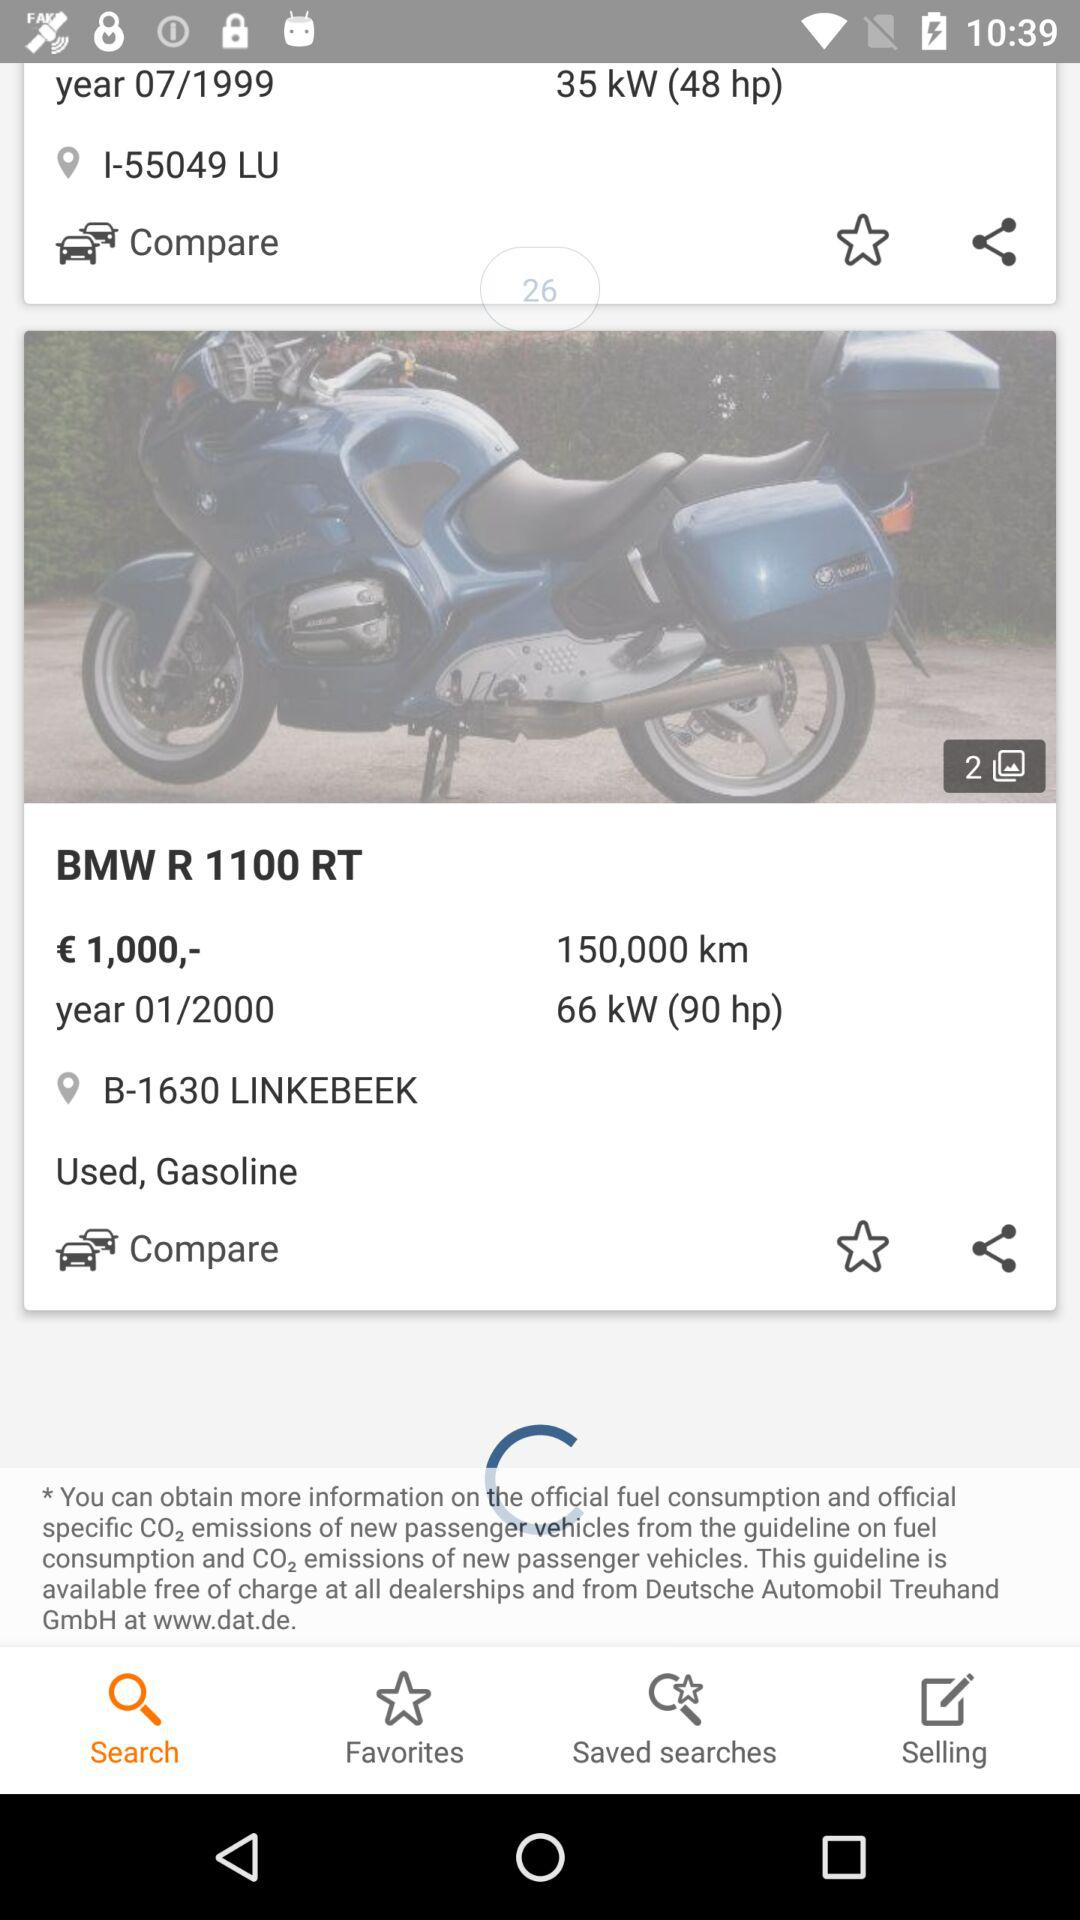How many photos are there? There are 2 photos. 